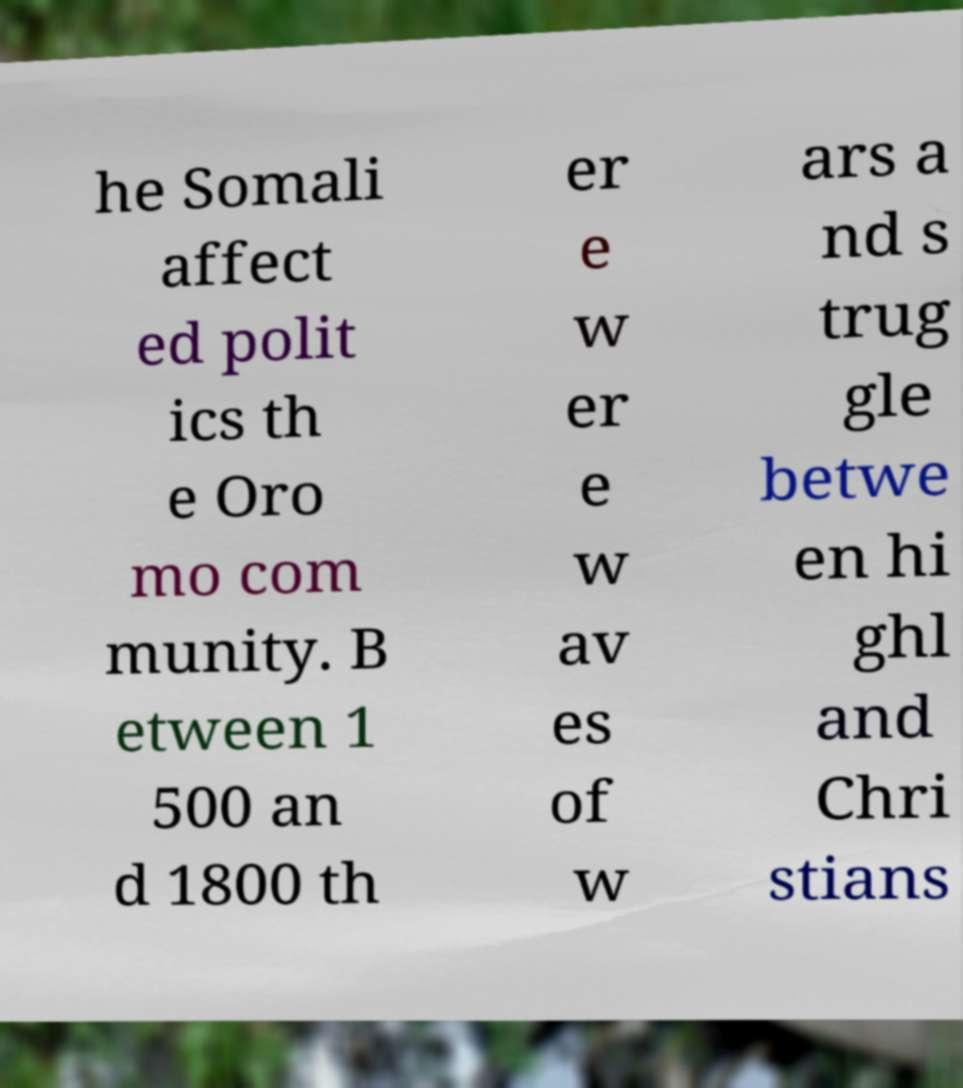There's text embedded in this image that I need extracted. Can you transcribe it verbatim? he Somali affect ed polit ics th e Oro mo com munity. B etween 1 500 an d 1800 th er e w er e w av es of w ars a nd s trug gle betwe en hi ghl and Chri stians 